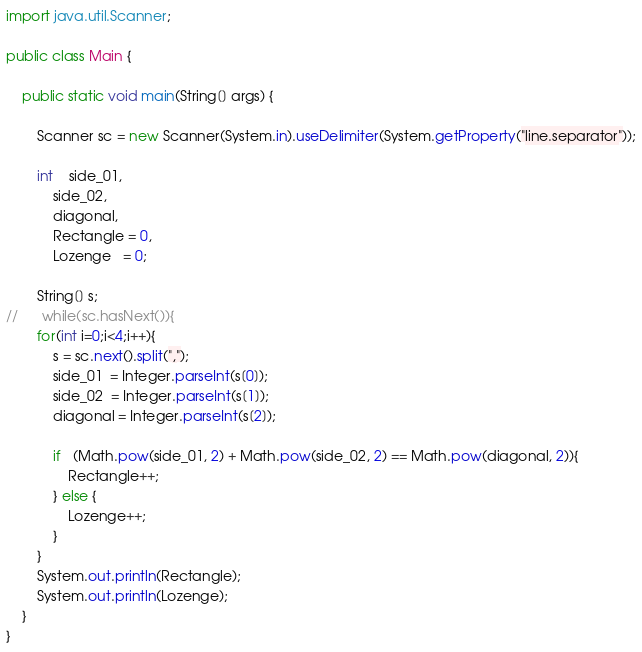Convert code to text. <code><loc_0><loc_0><loc_500><loc_500><_Java_>import java.util.Scanner;

public class Main {

    public static void main(String[] args) {

    	Scanner sc = new Scanner(System.in).useDelimiter(System.getProperty("line.separator"));

    	int	side_01,
    	    side_02,
    	    diagonal,
    	    Rectangle = 0,
    	    Lozenge   = 0;

    	String[] s;
//    	while(sc.hasNext()){
    	for(int i=0;i<4;i++){
    		s = sc.next().split(",");
    		side_01  = Integer.parseInt(s[0]);
    		side_02  = Integer.parseInt(s[1]);
    		diagonal = Integer.parseInt(s[2]);

    		if   (Math.pow(side_01, 2) + Math.pow(side_02, 2) == Math.pow(diagonal, 2)){
    			Rectangle++;
    		} else {
    			Lozenge++;
    		}
    	}
		System.out.println(Rectangle);
		System.out.println(Lozenge);
	}
}</code> 